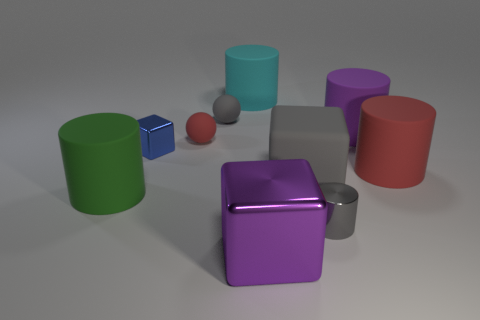Subtract all rubber blocks. How many blocks are left? 2 Subtract all gray cylinders. How many cylinders are left? 4 Subtract all spheres. How many objects are left? 8 Subtract 1 balls. How many balls are left? 1 Subtract all blue balls. Subtract all brown blocks. How many balls are left? 2 Subtract all cyan cylinders. Subtract all large red things. How many objects are left? 8 Add 1 metal blocks. How many metal blocks are left? 3 Add 1 red metallic cylinders. How many red metallic cylinders exist? 1 Subtract 0 purple balls. How many objects are left? 10 